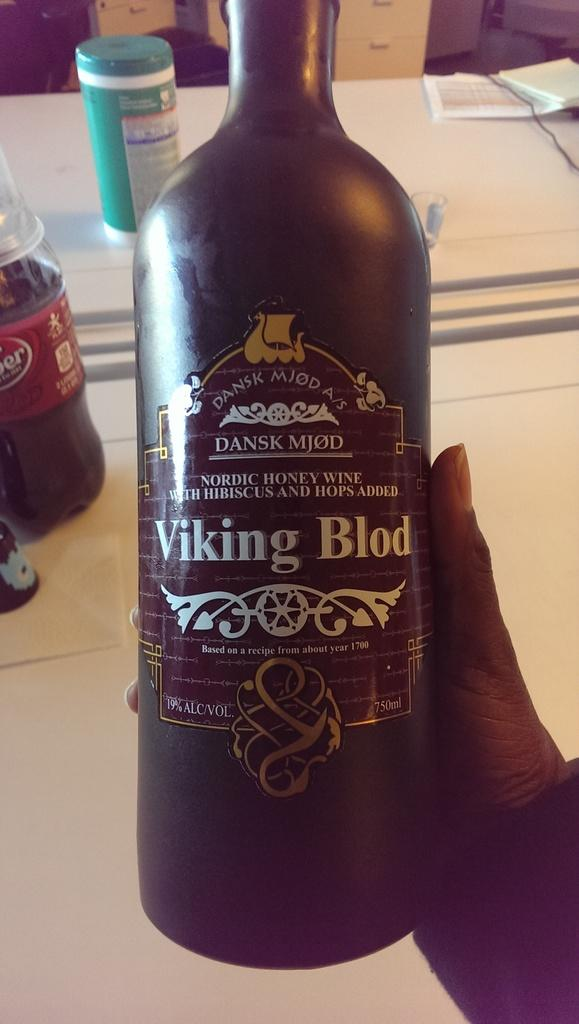<image>
Render a clear and concise summary of the photo. Person holding a beer bottle that is named "Viking Blod". 